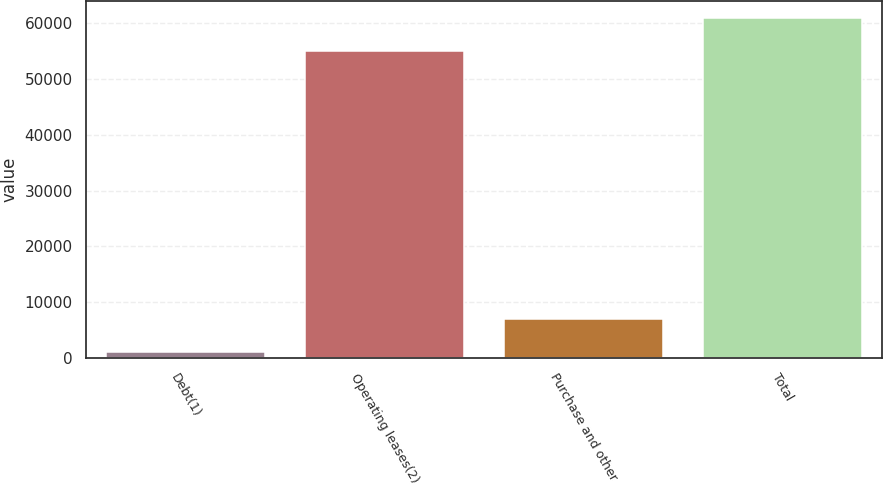Convert chart. <chart><loc_0><loc_0><loc_500><loc_500><bar_chart><fcel>Debt(1)<fcel>Operating leases(2)<fcel>Purchase and other<fcel>Total<nl><fcel>1080<fcel>54969<fcel>7042<fcel>60931<nl></chart> 